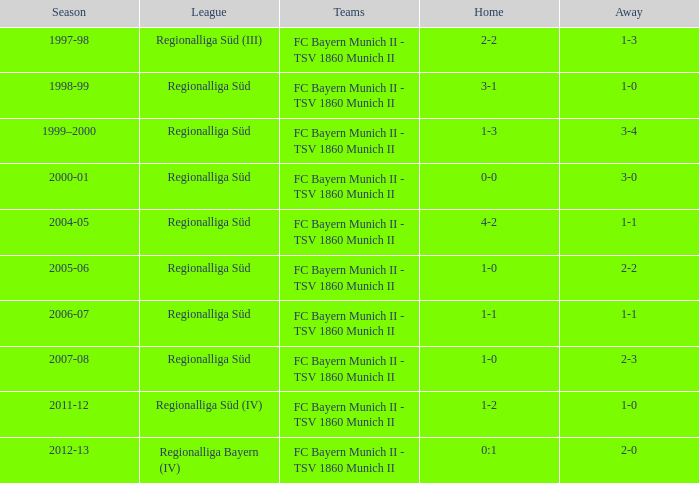Which season has the regionalliga süd (iii) league? 1997-98. 